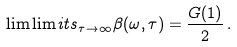<formula> <loc_0><loc_0><loc_500><loc_500>\lim \lim i t s _ { \tau \to \infty } \beta ( \omega , \tau ) = \frac { G ( 1 ) } { 2 } \, .</formula> 